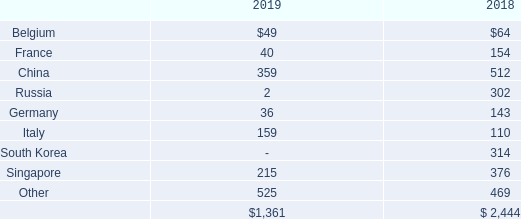Foreign Sales
Revenues in each of the Company’s segments include sales to foreign governments or to companies located in foreign countries. For the years ended April 30, 2019 and 2018, revenues, based on the location of the procurement entity and excluding intersegment sales, were derived from the following countries (in thousands):
What is the revenue from Belgium in 2019 and 2018 respectively?
Answer scale should be: thousand. $49, $64. What is the revenue from France in 2019 and 2018 respectively?
Answer scale should be: thousand. 40, 154. What does the table show? For the years ended april 30, 2019 and 2018, revenues, based on the location of the procurement entity and excluding intersegment sales. What is the average revenue from Singapore in 2018 and 2019?
Answer scale should be: thousand. (215+ 376)/2
Answer: 295.5. In 2019, how many countries have revenues of less than $100 thousand? Belgium ## France ## Russia ## Germany##South Korea
Answer: 5. In 2018, what is the difference in revenue between South Korea and Singapore?
Answer scale should be: thousand. 376-314
Answer: 62. 